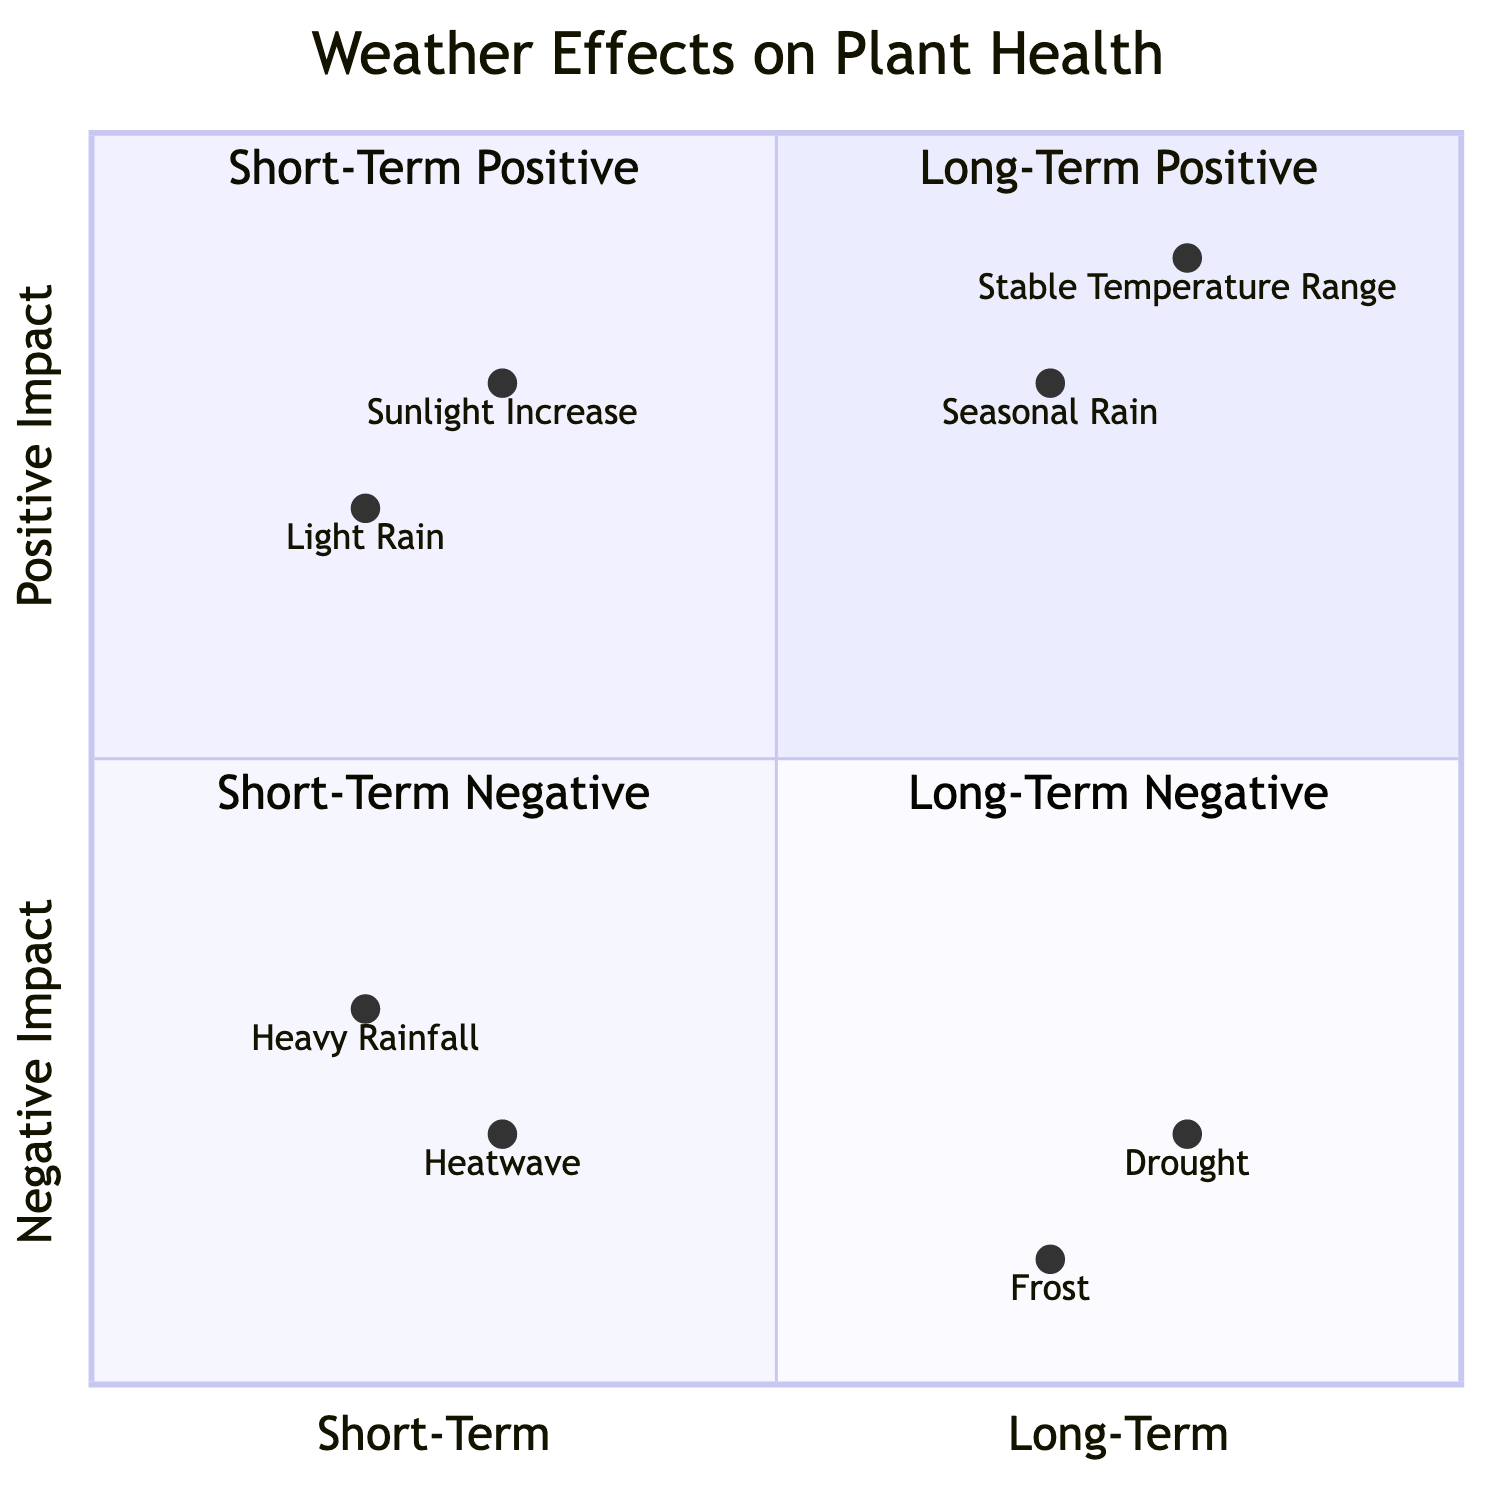What is the position of Heavy Rainfall in the diagram? Heavy Rainfall is placed in the short-term negative impact quadrant, which is located in quadrant 3, with coordinates [0.2, 0.3].
Answer: quadrant 3 Which factor has the highest long-term positive impact? Among the long-term positive impacts in the diagram, Stable Temperature Range has the highest value at coordinates [0.8, 0.9], making it the highest in that category.
Answer: Stable Temperature Range How many factors are categorized under long-term negative impact? In the diagram, there are two factors listed under long-term negative impacts: Drought and Frost. Therefore, the count is 2.
Answer: 2 What is the effect of Heatwave on plant health? Heatwave is listed in the short-term negative impact quadrant and is described as causing wilting and sunburn of leaves, thus showing a detrimental effect on health.
Answer: wilting and sunburn of leaves Which two factors occupy the highest quadrant based on impact? The two factors in the long-term positive impact quadrant at the highest position are Seasonal Rain and Stable Temperature Range, with coordinates indicating their position higher on the graph.
Answer: Seasonal Rain and Stable Temperature Range 